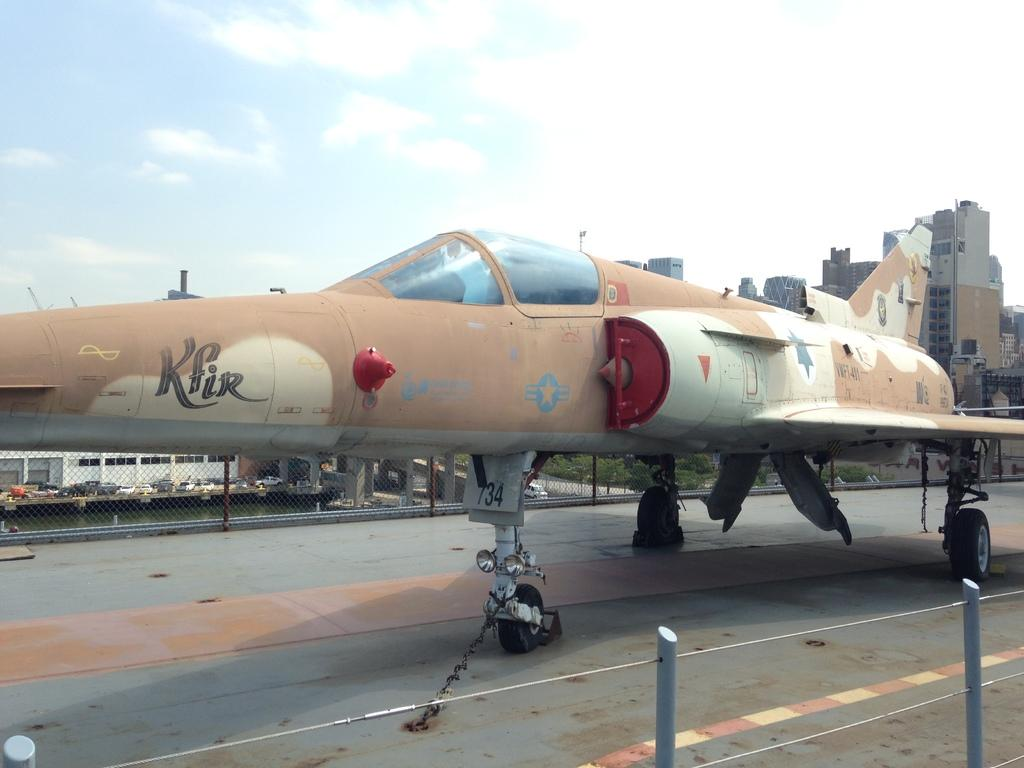<image>
Write a terse but informative summary of the picture. A tan and white fighter jet with the foreign word Kfir printed on the front. 